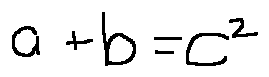Convert formula to latex. <formula><loc_0><loc_0><loc_500><loc_500>a + b = c ^ { 2 }</formula> 